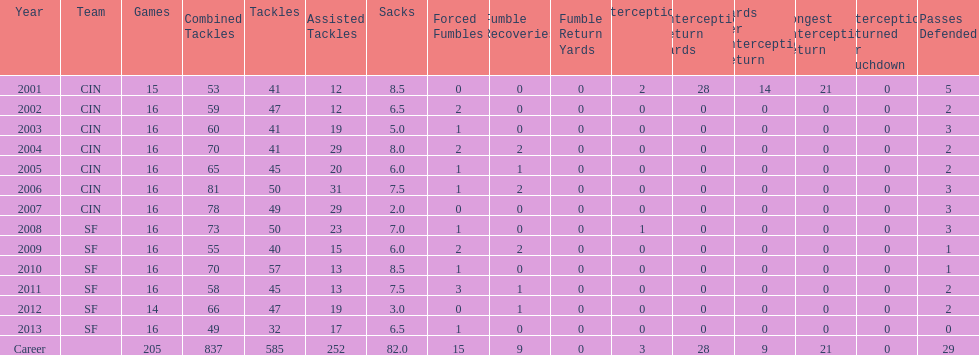How many years did he play in less than 16 games? 2. 